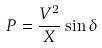Convert formula to latex. <formula><loc_0><loc_0><loc_500><loc_500>P = \frac { V ^ { 2 } } { X } \sin \delta</formula> 